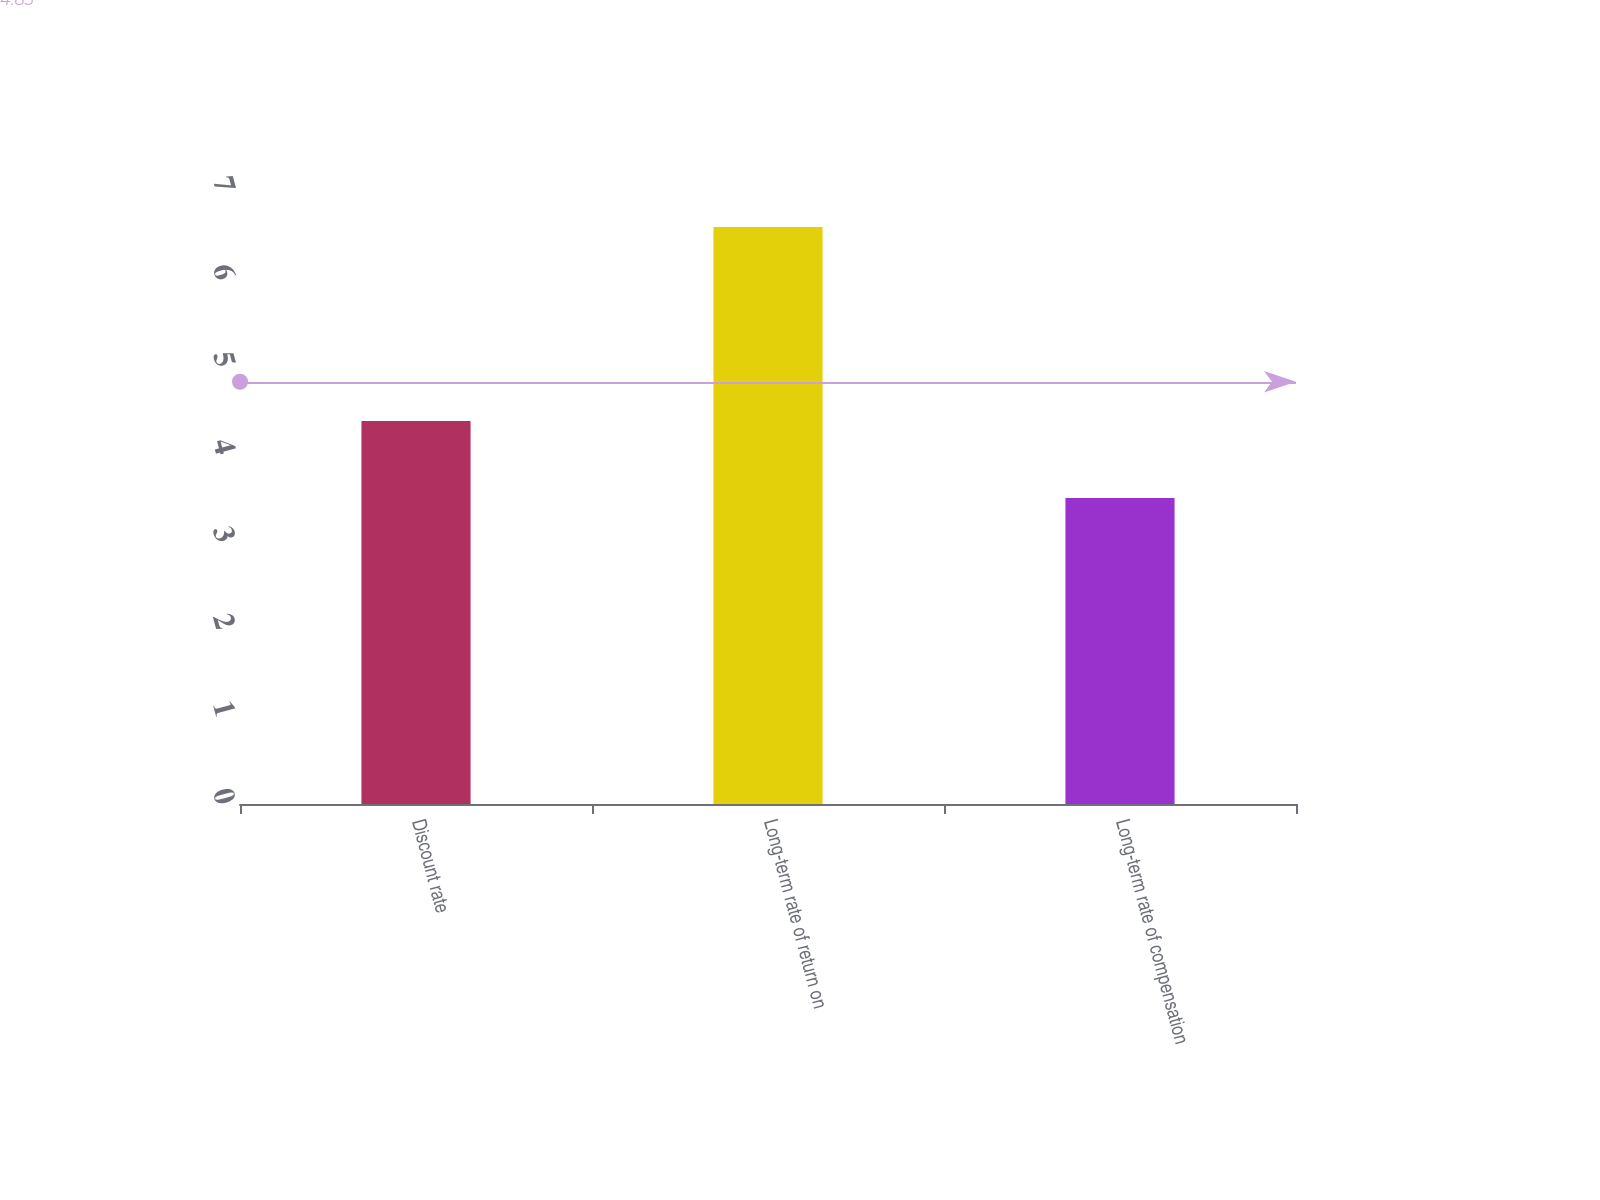Convert chart. <chart><loc_0><loc_0><loc_500><loc_500><bar_chart><fcel>Discount rate<fcel>Long-term rate of return on<fcel>Long-term rate of compensation<nl><fcel>4.38<fcel>6.6<fcel>3.5<nl></chart> 